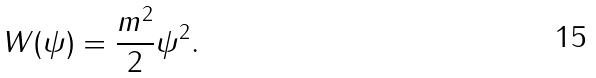<formula> <loc_0><loc_0><loc_500><loc_500>W ( \psi ) = \frac { m ^ { 2 } } { 2 } \psi ^ { 2 } .</formula> 